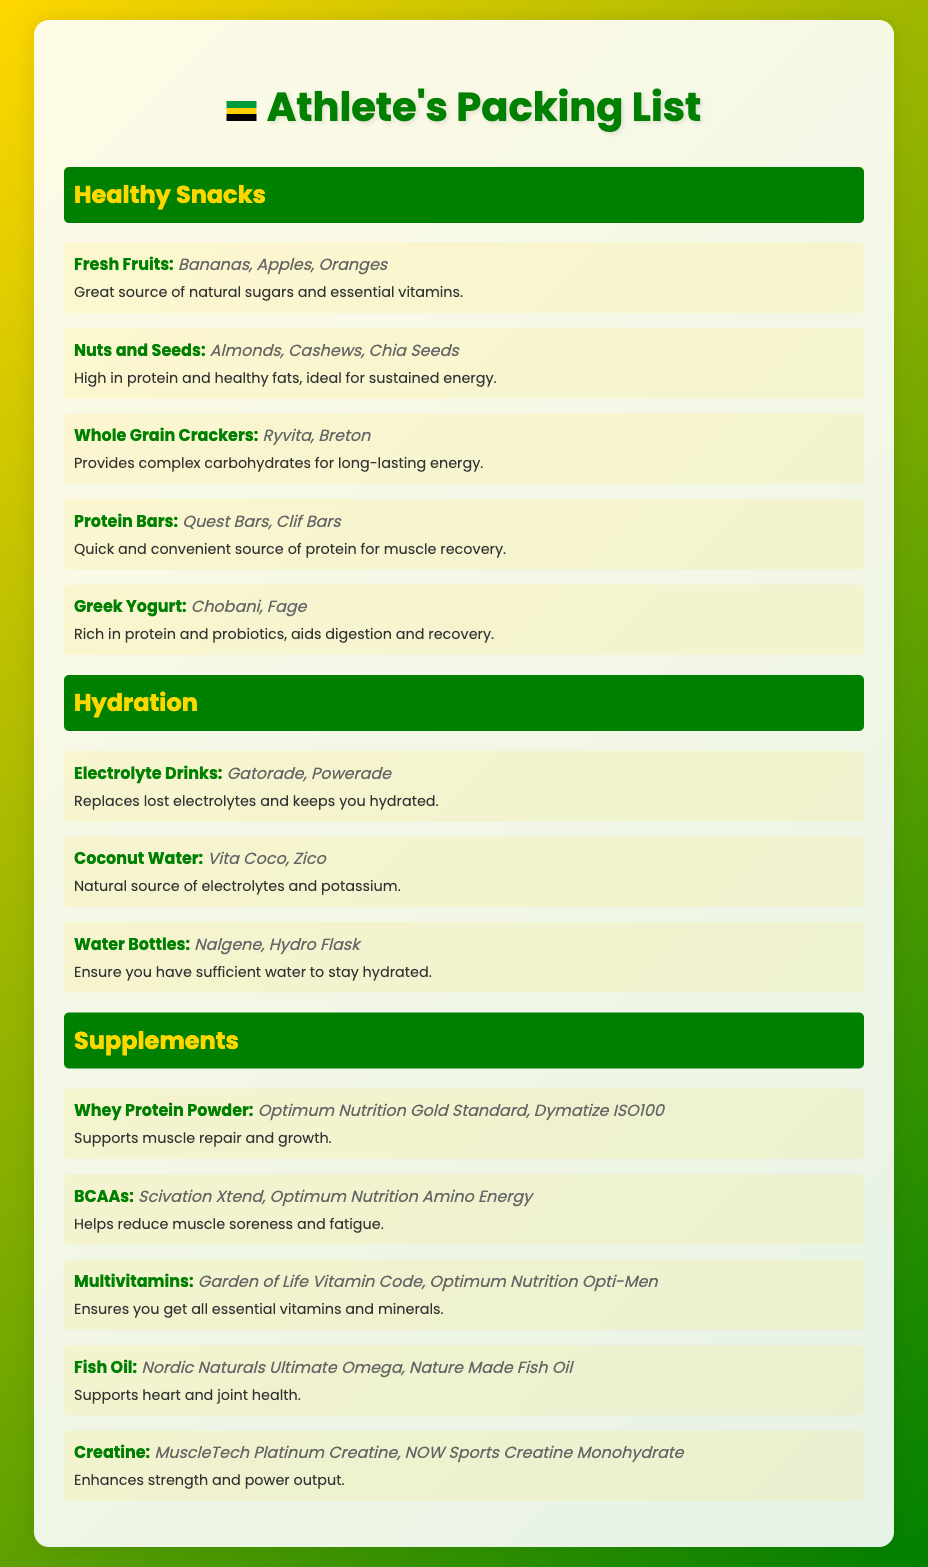What are some examples of fresh fruits? The document lists specific examples of fresh fruits suitable for packing, such as Bananas, Apples, and Oranges.
Answer: Bananas, Apples, Oranges What is the purpose of protein bars? The document states that protein bars serve as a quick and convenient source of protein for muscle recovery.
Answer: Quick and convenient source of protein for muscle recovery Which drink replaces lost electrolytes? The document mentions that electrolyte drinks like Gatorade and Powerade replace lost electrolytes and keep you hydrated.
Answer: Gatorade, Powerade What supplement supports muscle repair? The document identifies Whey Protein Powder as the supplement that supports muscle repair and growth.
Answer: Whey Protein Powder What type of snacks provide complex carbohydrates? The document indicates that Whole Grain Crackers provide complex carbohydrates for long-lasting energy.
Answer: Whole Grain Crackers Which item is rich in probiotics? The document specifies that Greek Yogurt is rich in protein and probiotics, aiding digestion and recovery.
Answer: Greek Yogurt How many healthy snack categories are listed? The document contains three main categories of healthy snacks: Healthy Snacks, Hydration, and Supplements.
Answer: Three What is an example of a multivitamin mentioned? The document provides examples of multivitamins, including Garden of Life Vitamin Code and Optimum Nutrition Opti-Men.
Answer: Garden of Life Vitamin Code, Optimum Nutrition Opti-Men Which nut is mentioned as a source of healthy fats? The document lists Almonds as a type of nut that is high in protein and healthy fats.
Answer: Almonds 